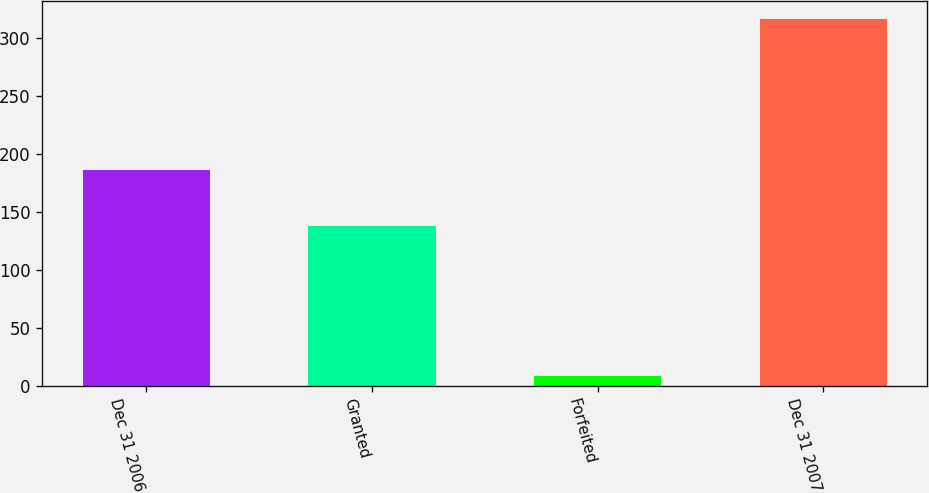Convert chart. <chart><loc_0><loc_0><loc_500><loc_500><bar_chart><fcel>Dec 31 2006<fcel>Granted<fcel>Forfeited<fcel>Dec 31 2007<nl><fcel>186<fcel>138<fcel>8<fcel>316<nl></chart> 